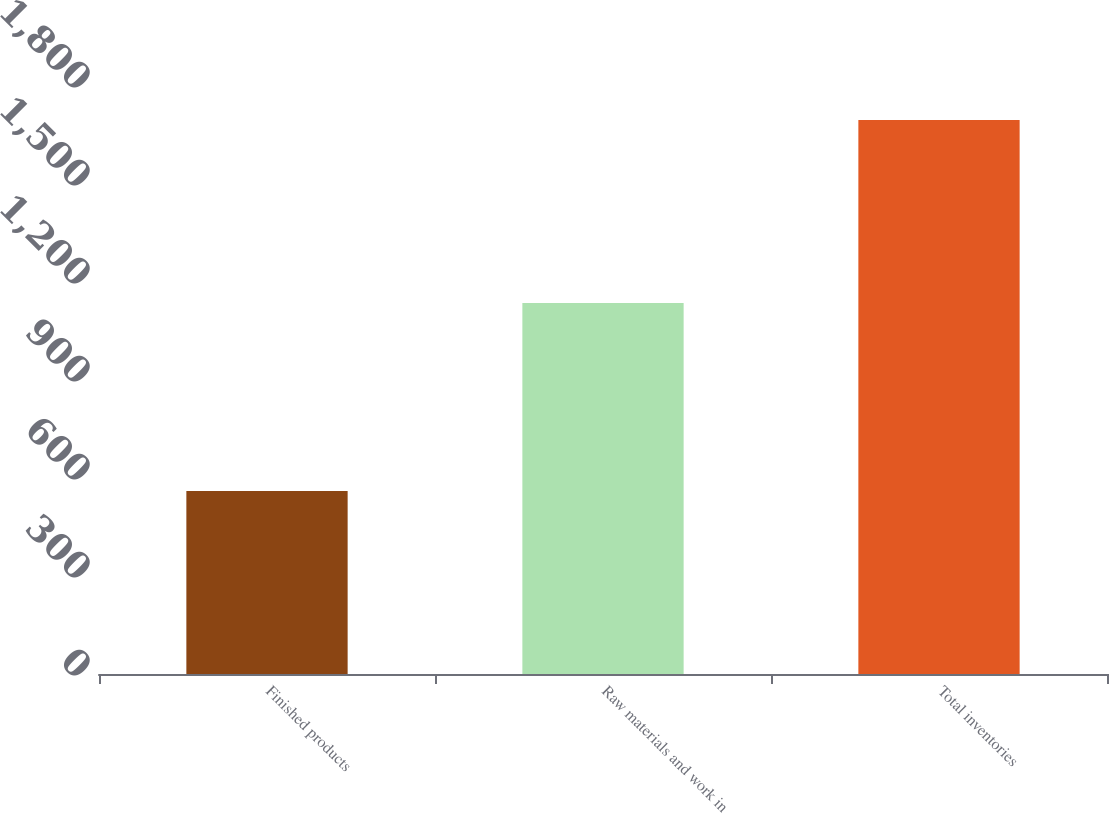<chart> <loc_0><loc_0><loc_500><loc_500><bar_chart><fcel>Finished products<fcel>Raw materials and work in<fcel>Total inventories<nl><fcel>560<fcel>1136<fcel>1696<nl></chart> 